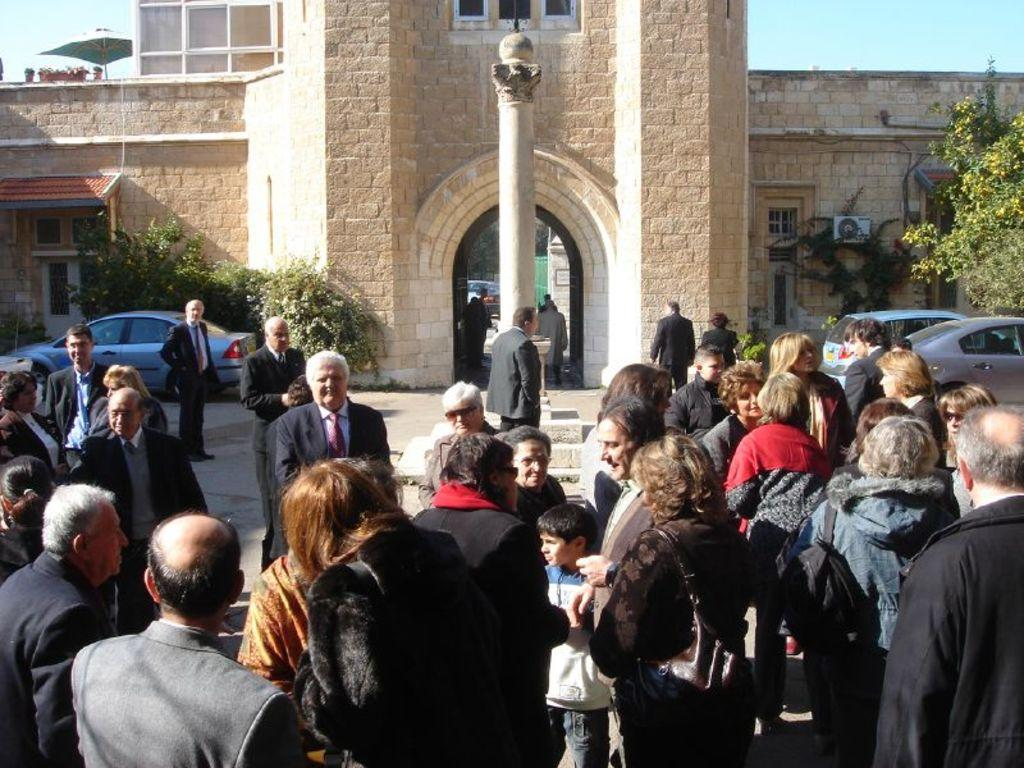How many people are in the group shown in the image? There is a group of people in the image, but the exact number is not specified. What are some people in the group wearing? Some people in the group are wearing bags. What can be seen in the background of the image? There are cars, trees, and a building visible in the image. What is on top of the building? There is an umbrella on the building. What type of balloon is being used as a prison for the people in the image? There is no balloon or prison present in the image; it features a group of people, cars, trees, a building, and an umbrella on the building. What is the shocking event that caused the people in the image to be in such a state? There is no shocking event or state mentioned in the image; it simply shows a group of people, cars, trees, a building, and an umbrella on the building. 